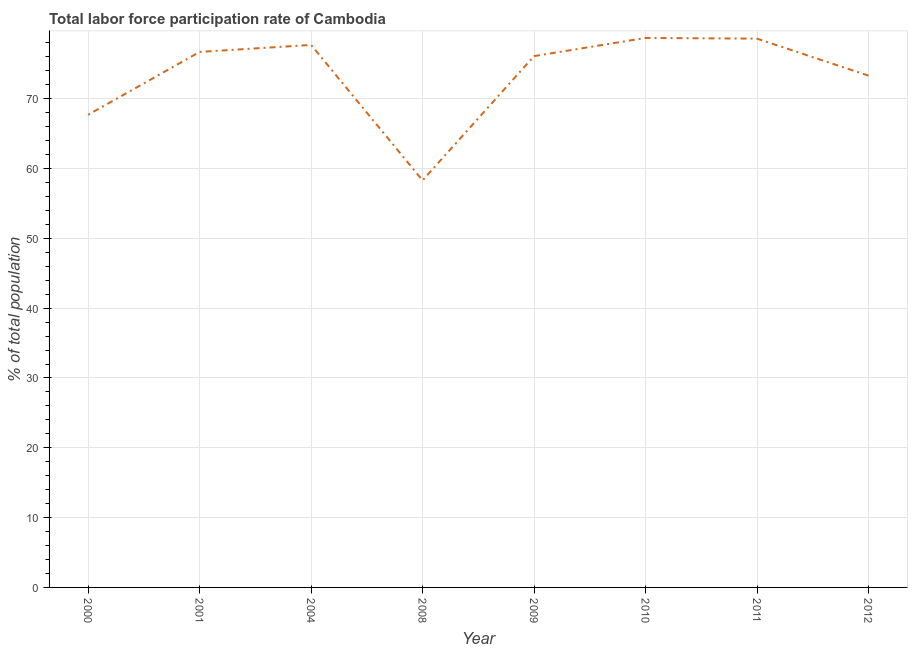What is the total labor force participation rate in 2001?
Ensure brevity in your answer.  76.7. Across all years, what is the maximum total labor force participation rate?
Ensure brevity in your answer.  78.7. Across all years, what is the minimum total labor force participation rate?
Offer a terse response. 58.3. In which year was the total labor force participation rate maximum?
Provide a succinct answer. 2010. In which year was the total labor force participation rate minimum?
Provide a succinct answer. 2008. What is the sum of the total labor force participation rate?
Ensure brevity in your answer.  587.1. What is the difference between the total labor force participation rate in 2004 and 2009?
Your answer should be very brief. 1.6. What is the average total labor force participation rate per year?
Offer a very short reply. 73.39. What is the median total labor force participation rate?
Offer a terse response. 76.4. In how many years, is the total labor force participation rate greater than 70 %?
Give a very brief answer. 6. Do a majority of the years between 2004 and 2012 (inclusive) have total labor force participation rate greater than 48 %?
Offer a terse response. Yes. What is the ratio of the total labor force participation rate in 2000 to that in 2008?
Offer a terse response. 1.16. Is the total labor force participation rate in 2004 less than that in 2011?
Your answer should be very brief. Yes. What is the difference between the highest and the second highest total labor force participation rate?
Provide a succinct answer. 0.1. What is the difference between the highest and the lowest total labor force participation rate?
Make the answer very short. 20.4. Does the total labor force participation rate monotonically increase over the years?
Provide a short and direct response. No. How many lines are there?
Keep it short and to the point. 1. What is the difference between two consecutive major ticks on the Y-axis?
Make the answer very short. 10. Are the values on the major ticks of Y-axis written in scientific E-notation?
Offer a terse response. No. What is the title of the graph?
Your response must be concise. Total labor force participation rate of Cambodia. What is the label or title of the X-axis?
Offer a very short reply. Year. What is the label or title of the Y-axis?
Keep it short and to the point. % of total population. What is the % of total population in 2000?
Keep it short and to the point. 67.7. What is the % of total population of 2001?
Ensure brevity in your answer.  76.7. What is the % of total population of 2004?
Offer a terse response. 77.7. What is the % of total population of 2008?
Offer a terse response. 58.3. What is the % of total population of 2009?
Provide a short and direct response. 76.1. What is the % of total population in 2010?
Your answer should be very brief. 78.7. What is the % of total population of 2011?
Provide a succinct answer. 78.6. What is the % of total population in 2012?
Keep it short and to the point. 73.3. What is the difference between the % of total population in 2000 and 2012?
Offer a terse response. -5.6. What is the difference between the % of total population in 2001 and 2004?
Your answer should be compact. -1. What is the difference between the % of total population in 2001 and 2010?
Offer a very short reply. -2. What is the difference between the % of total population in 2001 and 2011?
Ensure brevity in your answer.  -1.9. What is the difference between the % of total population in 2001 and 2012?
Keep it short and to the point. 3.4. What is the difference between the % of total population in 2004 and 2008?
Provide a short and direct response. 19.4. What is the difference between the % of total population in 2004 and 2009?
Offer a terse response. 1.6. What is the difference between the % of total population in 2004 and 2011?
Your answer should be compact. -0.9. What is the difference between the % of total population in 2004 and 2012?
Ensure brevity in your answer.  4.4. What is the difference between the % of total population in 2008 and 2009?
Offer a very short reply. -17.8. What is the difference between the % of total population in 2008 and 2010?
Provide a succinct answer. -20.4. What is the difference between the % of total population in 2008 and 2011?
Your answer should be compact. -20.3. What is the difference between the % of total population in 2009 and 2011?
Your response must be concise. -2.5. What is the difference between the % of total population in 2009 and 2012?
Your answer should be compact. 2.8. What is the difference between the % of total population in 2010 and 2011?
Your response must be concise. 0.1. What is the difference between the % of total population in 2010 and 2012?
Offer a terse response. 5.4. What is the difference between the % of total population in 2011 and 2012?
Provide a succinct answer. 5.3. What is the ratio of the % of total population in 2000 to that in 2001?
Your answer should be very brief. 0.88. What is the ratio of the % of total population in 2000 to that in 2004?
Provide a succinct answer. 0.87. What is the ratio of the % of total population in 2000 to that in 2008?
Make the answer very short. 1.16. What is the ratio of the % of total population in 2000 to that in 2009?
Offer a terse response. 0.89. What is the ratio of the % of total population in 2000 to that in 2010?
Ensure brevity in your answer.  0.86. What is the ratio of the % of total population in 2000 to that in 2011?
Give a very brief answer. 0.86. What is the ratio of the % of total population in 2000 to that in 2012?
Your answer should be compact. 0.92. What is the ratio of the % of total population in 2001 to that in 2008?
Offer a terse response. 1.32. What is the ratio of the % of total population in 2001 to that in 2011?
Keep it short and to the point. 0.98. What is the ratio of the % of total population in 2001 to that in 2012?
Provide a succinct answer. 1.05. What is the ratio of the % of total population in 2004 to that in 2008?
Keep it short and to the point. 1.33. What is the ratio of the % of total population in 2004 to that in 2012?
Give a very brief answer. 1.06. What is the ratio of the % of total population in 2008 to that in 2009?
Make the answer very short. 0.77. What is the ratio of the % of total population in 2008 to that in 2010?
Make the answer very short. 0.74. What is the ratio of the % of total population in 2008 to that in 2011?
Your response must be concise. 0.74. What is the ratio of the % of total population in 2008 to that in 2012?
Your answer should be compact. 0.8. What is the ratio of the % of total population in 2009 to that in 2010?
Provide a succinct answer. 0.97. What is the ratio of the % of total population in 2009 to that in 2012?
Your answer should be very brief. 1.04. What is the ratio of the % of total population in 2010 to that in 2011?
Make the answer very short. 1. What is the ratio of the % of total population in 2010 to that in 2012?
Provide a succinct answer. 1.07. What is the ratio of the % of total population in 2011 to that in 2012?
Your answer should be compact. 1.07. 